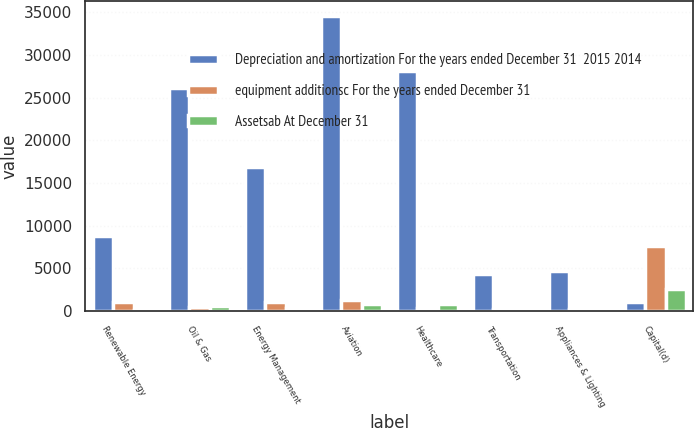<chart> <loc_0><loc_0><loc_500><loc_500><stacked_bar_chart><ecel><fcel>Renewable Energy<fcel>Oil & Gas<fcel>Energy Management<fcel>Aviation<fcel>Healthcare<fcel>Transportation<fcel>Appliances & Lighting<fcel>Capital(d)<nl><fcel>Depreciation and amortization For the years ended December 31  2015 2014<fcel>8726<fcel>26126<fcel>16808<fcel>34524<fcel>28162<fcel>4368<fcel>4702<fcel>999<nl><fcel>equipment additionsc For the years ended December 31<fcel>999<fcel>422<fcel>1073<fcel>1260<fcel>284<fcel>202<fcel>275<fcel>7570<nl><fcel>Assetsab At December 31<fcel>116<fcel>596<fcel>322<fcel>855<fcel>799<fcel>179<fcel>103<fcel>2584<nl></chart> 